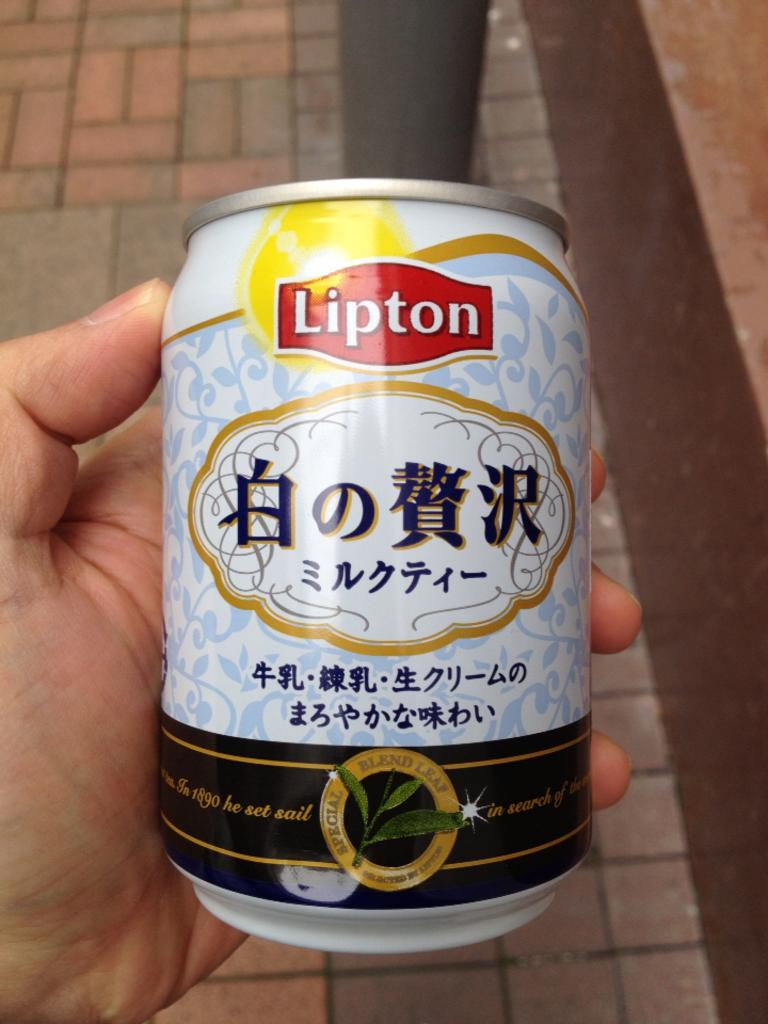<image>
Share a concise interpretation of the image provided. A can of Lipton special blend leaf tea with light blue flowery desing on a white background and Asian lettering. 